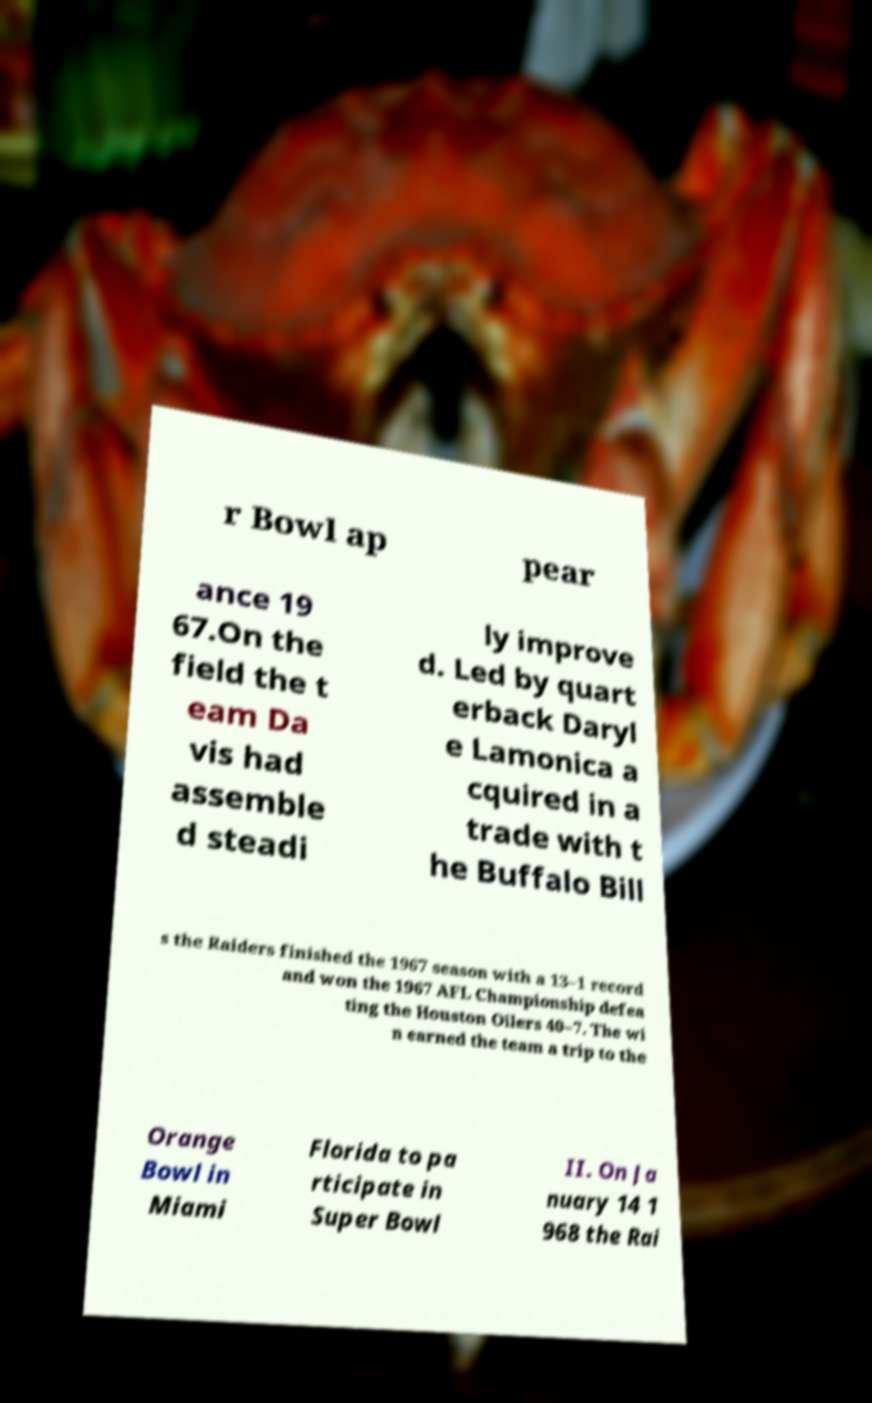Please identify and transcribe the text found in this image. r Bowl ap pear ance 19 67.On the field the t eam Da vis had assemble d steadi ly improve d. Led by quart erback Daryl e Lamonica a cquired in a trade with t he Buffalo Bill s the Raiders finished the 1967 season with a 13–1 record and won the 1967 AFL Championship defea ting the Houston Oilers 40–7. The wi n earned the team a trip to the Orange Bowl in Miami Florida to pa rticipate in Super Bowl II. On Ja nuary 14 1 968 the Rai 